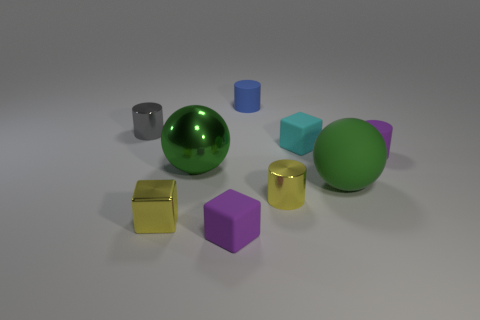What material is the blue cylinder behind the green object behind the big matte ball made of?
Your answer should be compact. Rubber. Is the number of purple rubber cubes that are behind the tiny purple cylinder greater than the number of small cyan things?
Make the answer very short. No. Is there a metal block?
Make the answer very short. Yes. What color is the tiny metallic cylinder in front of the large metallic object?
Offer a terse response. Yellow. There is a yellow object that is the same size as the metallic cube; what material is it?
Your answer should be compact. Metal. What number of other things are made of the same material as the blue object?
Give a very brief answer. 4. There is a tiny cube that is in front of the small purple rubber cylinder and on the right side of the yellow shiny cube; what is its color?
Your response must be concise. Purple. How many objects are either rubber cylinders that are on the right side of the yellow cylinder or cylinders?
Keep it short and to the point. 4. What number of other things are the same color as the large metal thing?
Give a very brief answer. 1. Is the number of tiny purple rubber cylinders behind the small gray metallic cylinder the same as the number of green rubber balls?
Offer a terse response. No. 